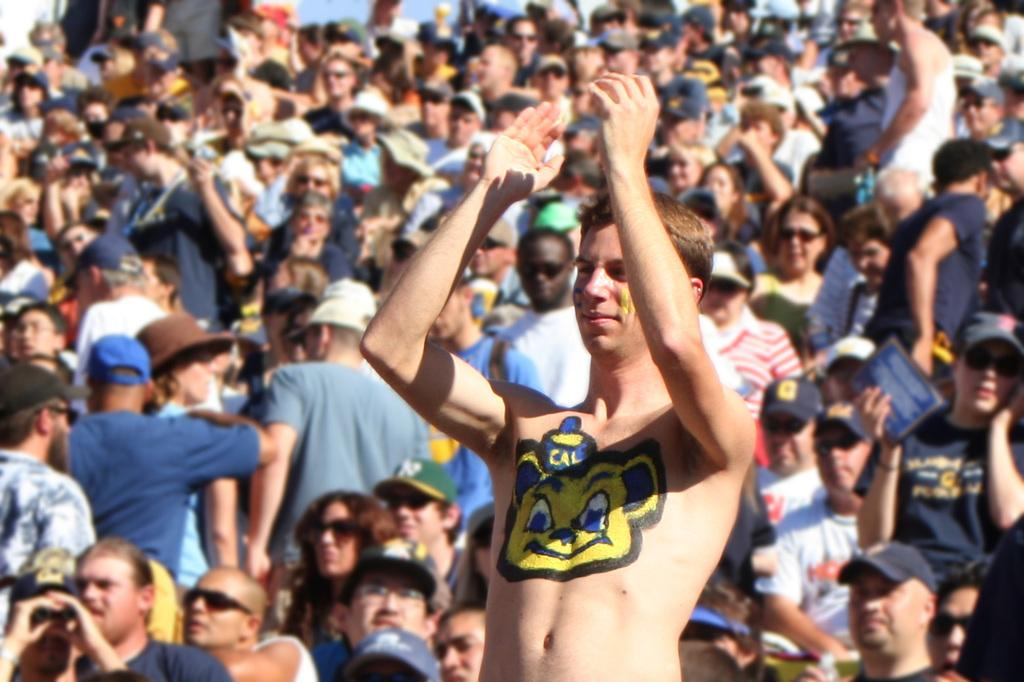What is the main subject of the image? There is a person in the image. What is unique about the person's appearance? The person has painting on their chest. Can you describe the setting of the image? There is a group of people in the background of the image. What type of airplane can be seen flying in the image? There is no airplane visible in the image; it only features a person with painting on their chest and a group of people in the background. 